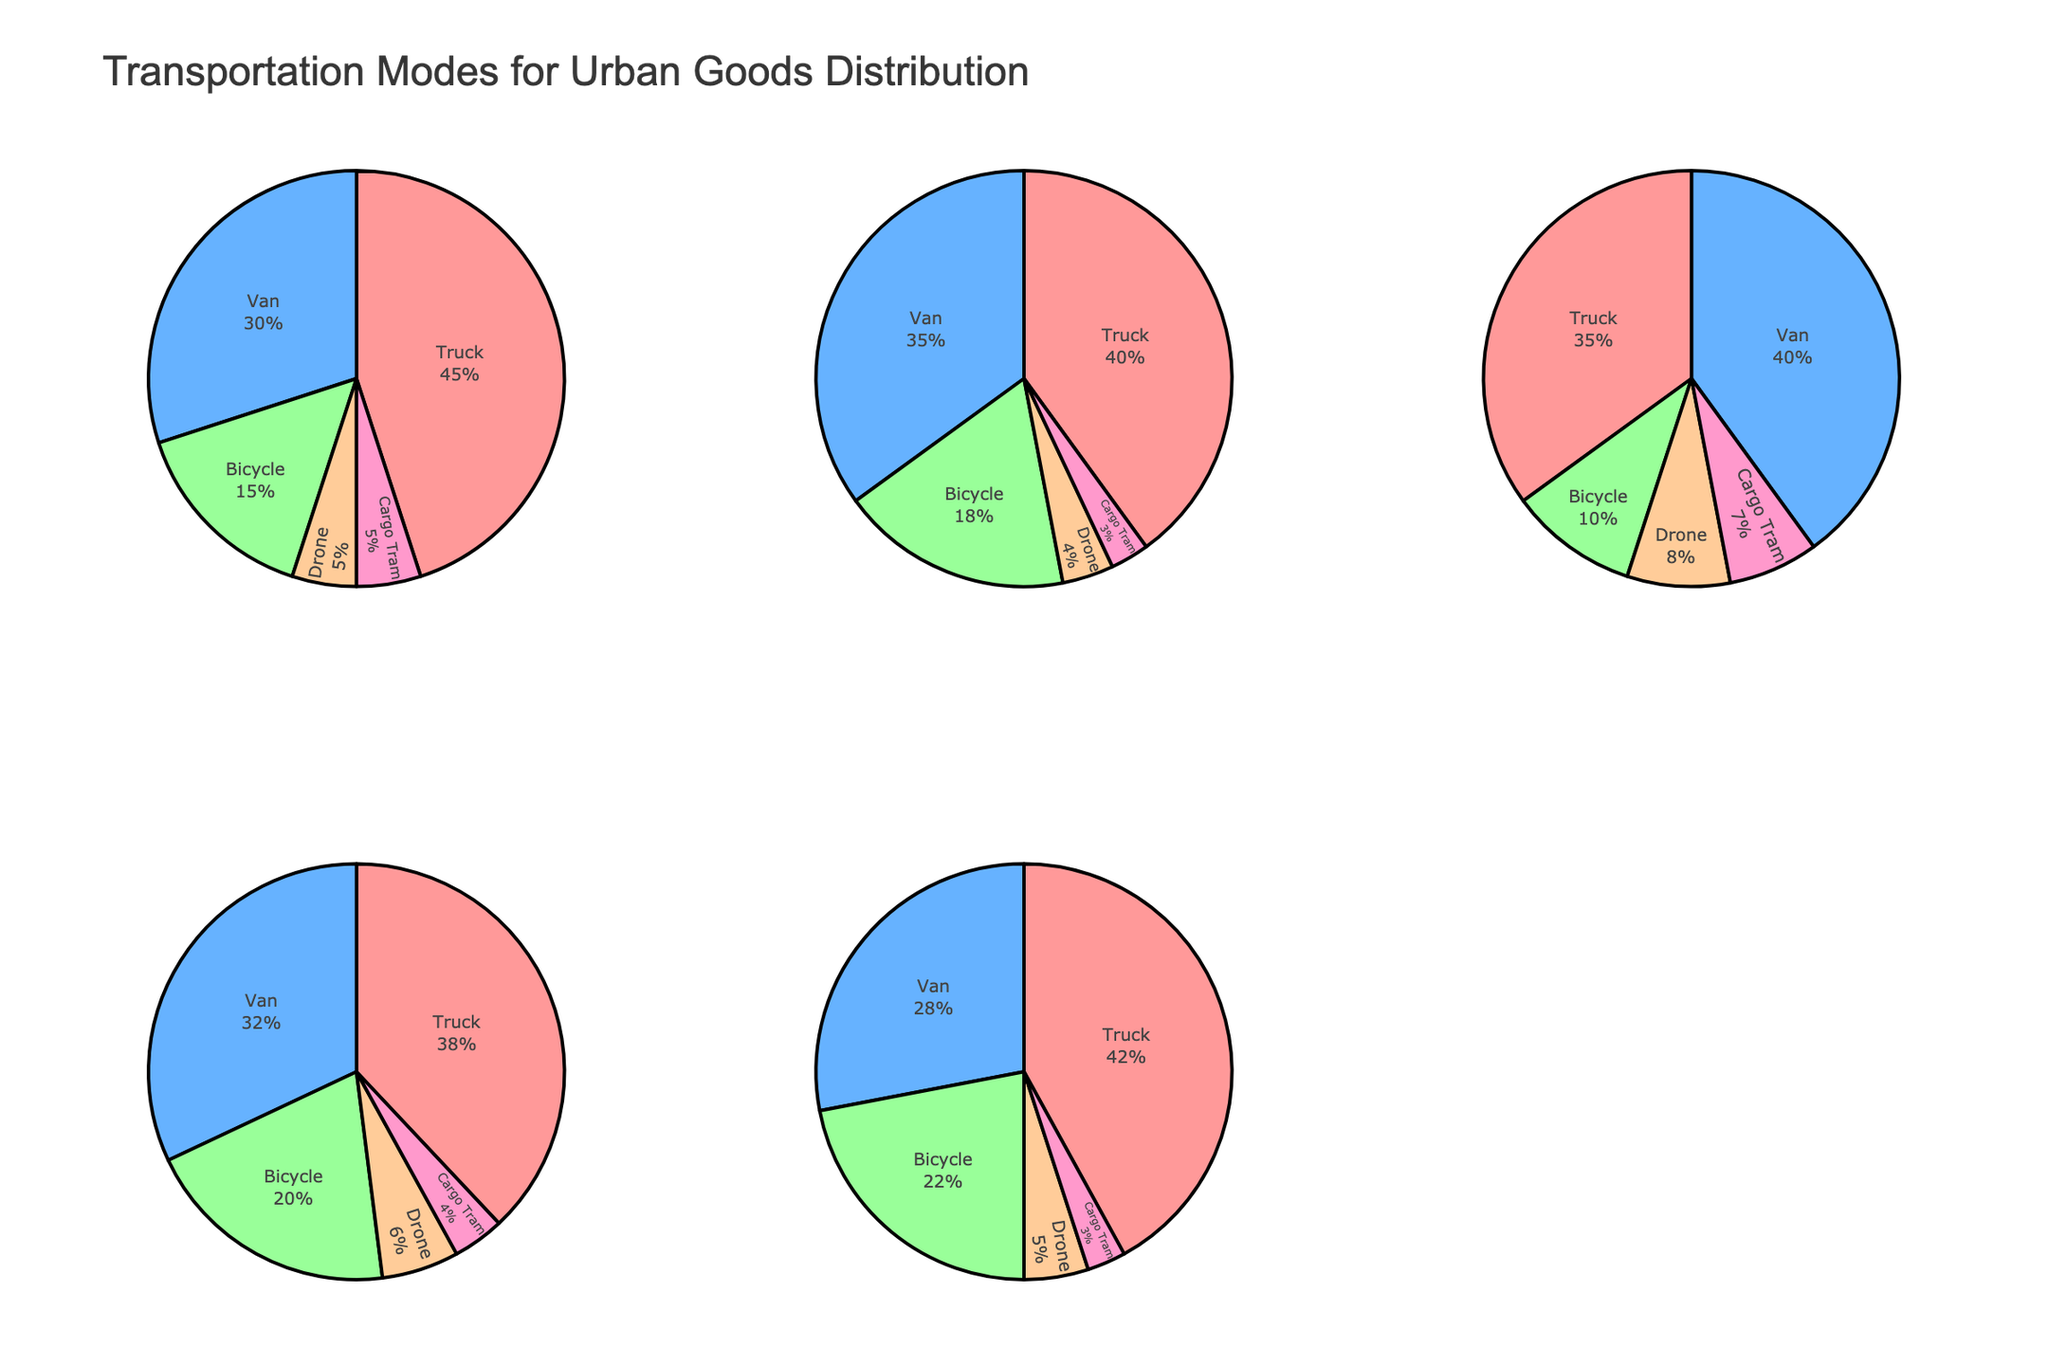What is the most used transportation mode in Paris? By observing the pie chart for Paris, the segment representing 'Bicycle' is the largest, indicating it's the most used transportation mode.
Answer: Bicycle Which city uses vans the most for goods distribution? By comparing all the pie charts, London has the largest percentage segment dedicated to 'Van', indicating it uses vans the most.
Answer: London What percentage of goods distribution in New York is handled by drones? Referring to the pie chart for New York, the segment for 'Drone' is labeled with its percentage.
Answer: 5% How many cities have drones used for more than 5% of goods distribution? By looking at the pie charts, Tokyo (8%) and Paris (6%) have more than 5% goods distribution by drones.
Answer: 2 Compare the use of trucks between New York and Berlin. In New York, 45% of goods distribution uses trucks, while in Berlin it's 42%. Thus, New York relies slightly more on trucks.
Answer: New York Which transportation mode is used least frequently in London? The pie chart for London has the smallest segment for 'Cargo Tram' at 3%.
Answer: Cargo Tram Are vans or bicycles more commonly used in Tokyo? In the pie chart for Tokyo, the 'Van' segment is larger (40%) compared to the 'Bicycle' segment (10%), indicating vans are more commonly used.
Answer: Vans What is the combined percentage of cargo trams used in all five cities? Adding the percentages of cargo tram segments in each city's pie chart: 5% (New York) + 3% (London) + 7% (Tokyo) + 4% (Paris) + 3% (Berlin) equals 22%.
Answer: 22% Calculate the average percentage of drones used among the five cities. The percentages are New York (5%), London (4%), Tokyo (8%), Paris (6%), Berlin (5%). Adding them up gives 28% and dividing by 5 gives an average of 5.6%.
Answer: 5.6% Which city's pie chart has the most even distribution among its transportation modes? By observing all cities' pie charts, Tokyo’s transportation mode segments appear most evenly distributed without any extreme values.
Answer: Tokyo 